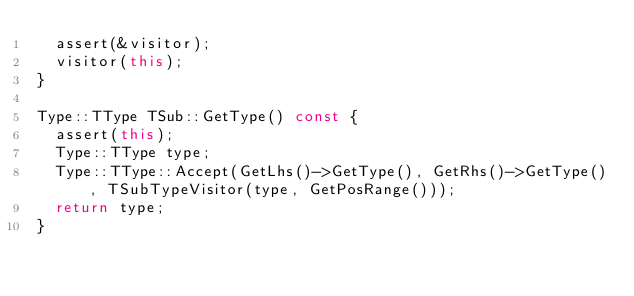<code> <loc_0><loc_0><loc_500><loc_500><_C++_>  assert(&visitor);
  visitor(this);
}

Type::TType TSub::GetType() const {
  assert(this);
  Type::TType type;
  Type::TType::Accept(GetLhs()->GetType(), GetRhs()->GetType(), TSubTypeVisitor(type, GetPosRange()));
  return type;
}

</code> 